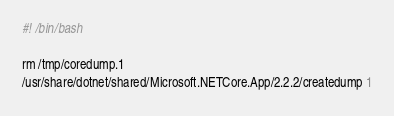Convert code to text. <code><loc_0><loc_0><loc_500><loc_500><_Bash_>#! /bin/bash

rm /tmp/coredump.1
/usr/share/dotnet/shared/Microsoft.NETCore.App/2.2.2/createdump 1</code> 